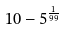Convert formula to latex. <formula><loc_0><loc_0><loc_500><loc_500>1 0 - 5 ^ { \frac { 1 } { 9 9 } }</formula> 